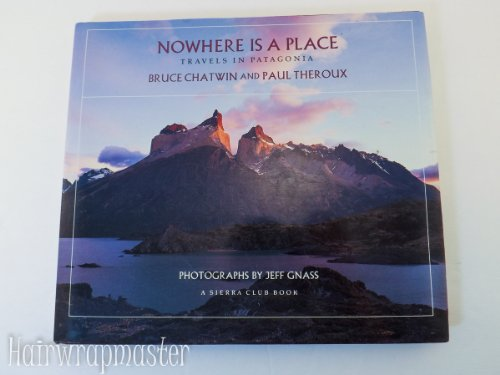Who wrote this book?
Answer the question using a single word or phrase. Bruce Chatwin What is the title of this book? Nowhere Is a Place Travels in Patagonia a Sierra Club Book (Hardback) What type of book is this? Travel Is this book related to Travel? Yes Is this book related to Mystery, Thriller & Suspense? No 